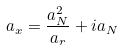Convert formula to latex. <formula><loc_0><loc_0><loc_500><loc_500>a _ { x } = \frac { a _ { N } ^ { 2 } } { a _ { r } } + i a _ { N }</formula> 